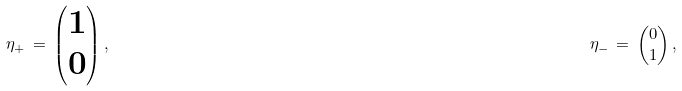<formula> <loc_0><loc_0><loc_500><loc_500>\eta _ { + } \, = \, \begin{pmatrix} 1 \\ 0 \end{pmatrix} , & & \eta _ { - } \, = \, \begin{pmatrix} 0 \\ 1 \end{pmatrix} ,</formula> 